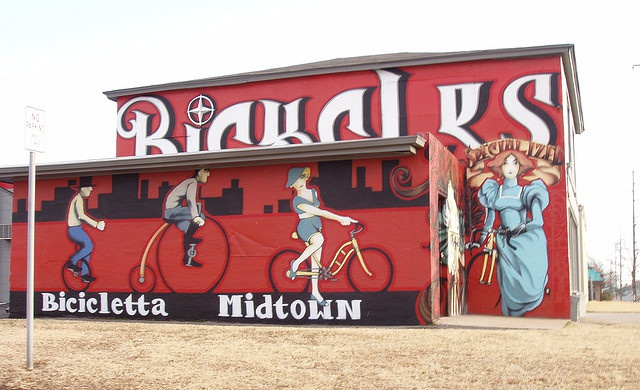Describe the objects in this image and their specific colors. I can see people in white, lightblue, gray, and darkgray tones, bicycle in white, brown, and maroon tones, bicycle in white, brown, and maroon tones, people in white, lightgray, darkgray, and gray tones, and people in white, darkgray, gray, black, and maroon tones in this image. 